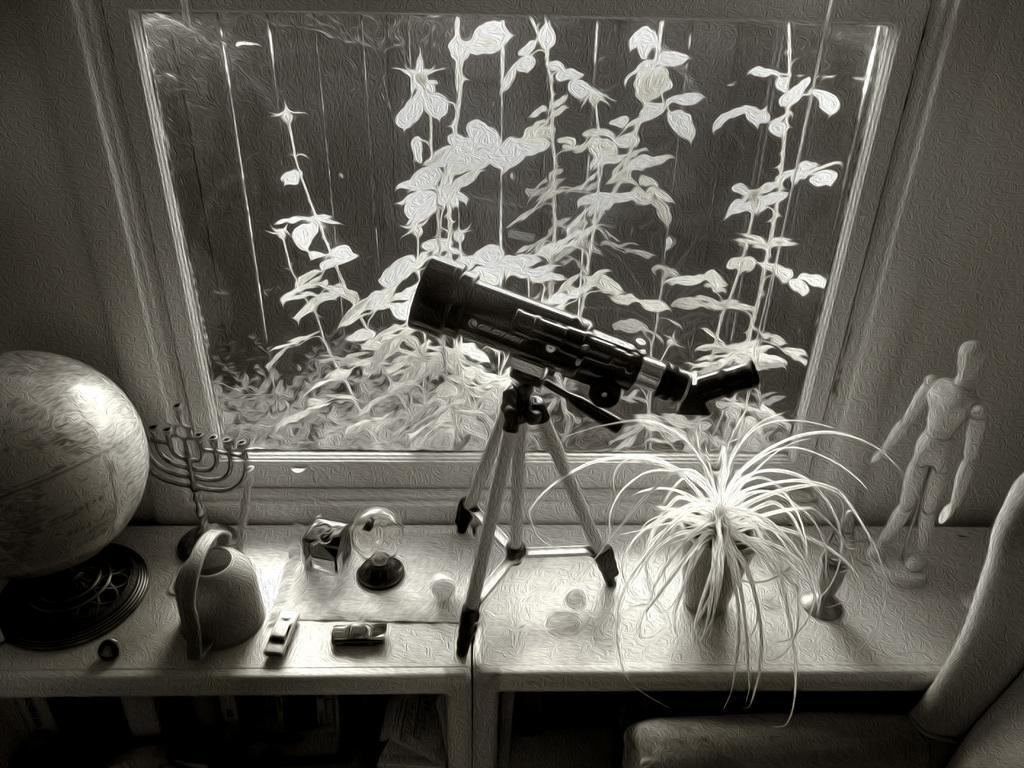How would you summarize this image in a sentence or two? This picture shows a telescope to the stand and few plants and a plant in the pot and a globe and we see few toys on the table and a chair. 